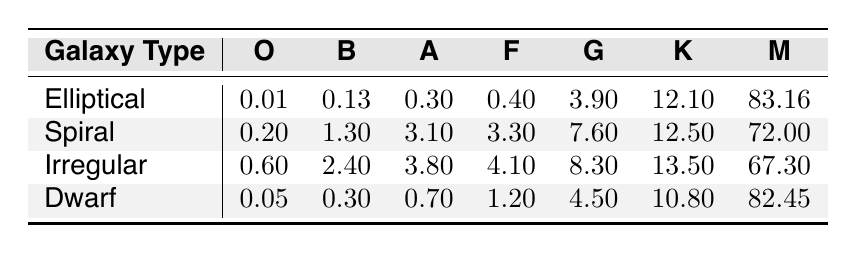What spectral class has the highest value in the Elliptical galaxies? By examining the data for Elliptical galaxies, the column with the maximum value is M, which has a value of 83.16.
Answer: M Which galaxy type has the lowest percentage of spectral class O stars? In the table, the Dwarf galaxy type has the smallest value for spectral class O, with a percentage of 0.05.
Answer: Dwarf What is the total percentage of spectral class M stars across all galaxy types? To find the total for class M, we add the values: 83.16 (Elliptical) + 72.00 (Spiral) + 67.30 (Irregular) + 82.45 (Dwarf) = 304.91.
Answer: 304.91 Is there a galaxy type that has no spectral class G stars? Reviewing the table, all galaxy types (Elliptical, Spiral, Irregular, and Dwarf) have values for spectral class G stars, so the answer is no.
Answer: No Which spectral class has the greatest difference in percentage between the Spiral and Dwarf galaxy types? By calculating the differences for each spectral class: O (0.2 - 0.05 = 0.15), B (1.3 - 0.3 = 1.0), A (3.1 - 0.7 = 2.4), F (3.3 - 1.2 = 2.1), G (7.6 - 4.5 = 3.1), K (12.5 - 10.8 = 1.7), M (72 - 82.45 = -10.45). The largest difference is for class G, with 3.1.
Answer: G What is the average value of spectral class K stars across the four types of galaxies? Calculate the average by first summing the values: 12.10 (Elliptical) + 12.50 (Spiral) + 13.50 (Irregular) + 10.80 (Dwarf) = 48.90. Then divide by 4 (the number of galaxy types): 48.90 / 4 = 12.225.
Answer: 12.225 Does the Irregular galaxy type have a higher percentage of class B stars than Spiral galaxies? Comparing the values, Irregular has 2.4, while Spiral has 1.3. Since 2.4 is greater than 1.3, the answer is yes.
Answer: Yes Which galaxy type has the highest total average of spectral classes A, F, and G combined? To find the total for A, F, and G across galaxy types: (0.3 + 0.4 + 3.9) for Elliptical = 4.6, (3.1 + 3.3 + 7.6) for Spiral = 14.0, (3.8 + 4.1 + 8.3) for Irregular = 16.2, and (0.7 + 1.2 + 4.5) for Dwarf = 6.4. The highest total is for Irregular with 16.2.
Answer: Irregular 